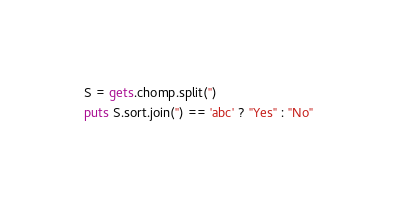<code> <loc_0><loc_0><loc_500><loc_500><_Ruby_>S = gets.chomp.split('')
puts S.sort.join('') == 'abc' ? "Yes" : "No"
</code> 